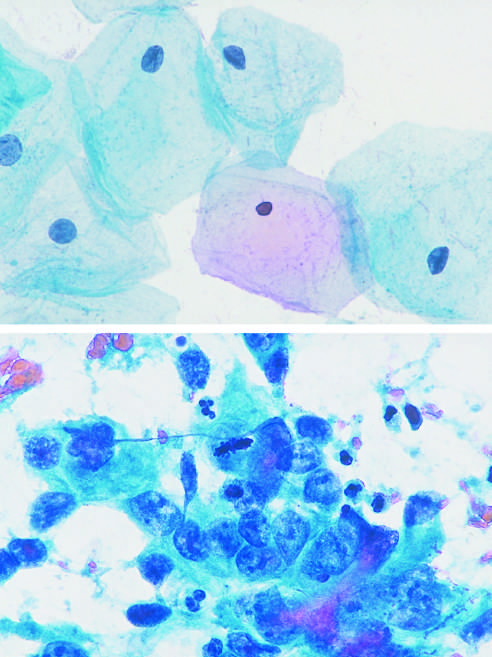how many cells are in mitosis?
Answer the question using a single word or phrase. One 